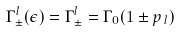<formula> <loc_0><loc_0><loc_500><loc_500>\Gamma ^ { l } _ { \pm } ( \epsilon ) = \Gamma ^ { l } _ { \pm } = \Gamma _ { 0 } ( 1 \pm { p _ { \, l } } )</formula> 